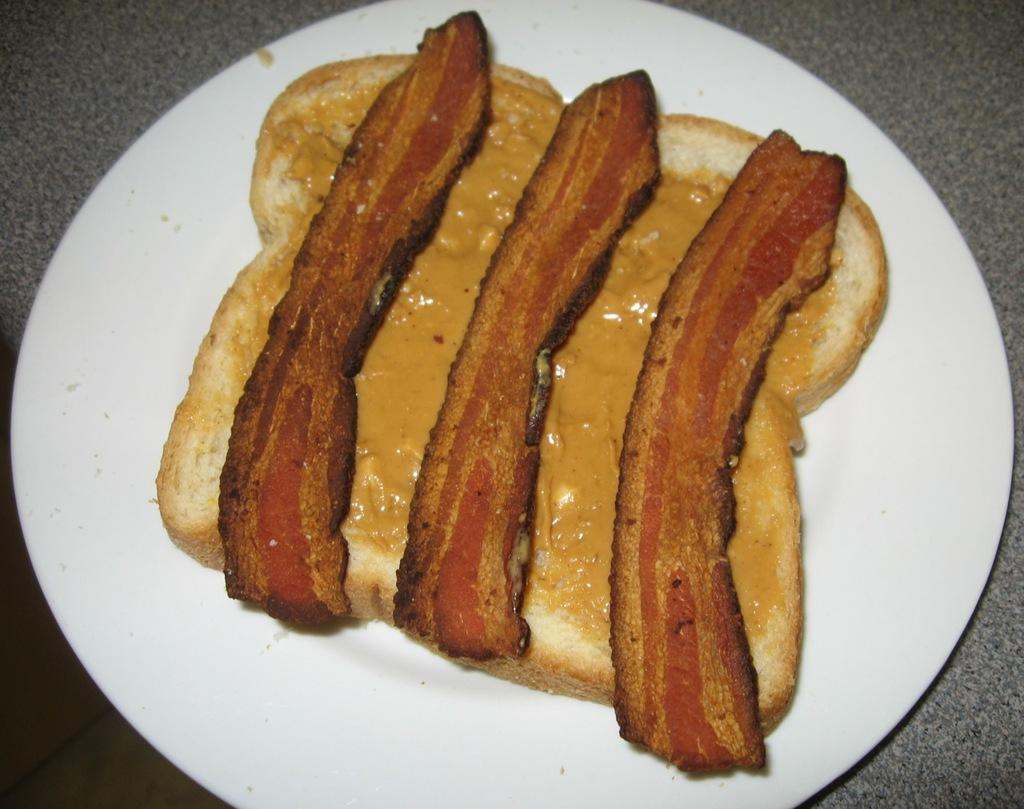What color is the plate that is visible in the image? The plate in the image is white. What is on the plate in the image? There is food on the plate in the image. What type of trade is being conducted by the band in the image? There is no band or trade present in the image; it only features a white color plate with food on it. 